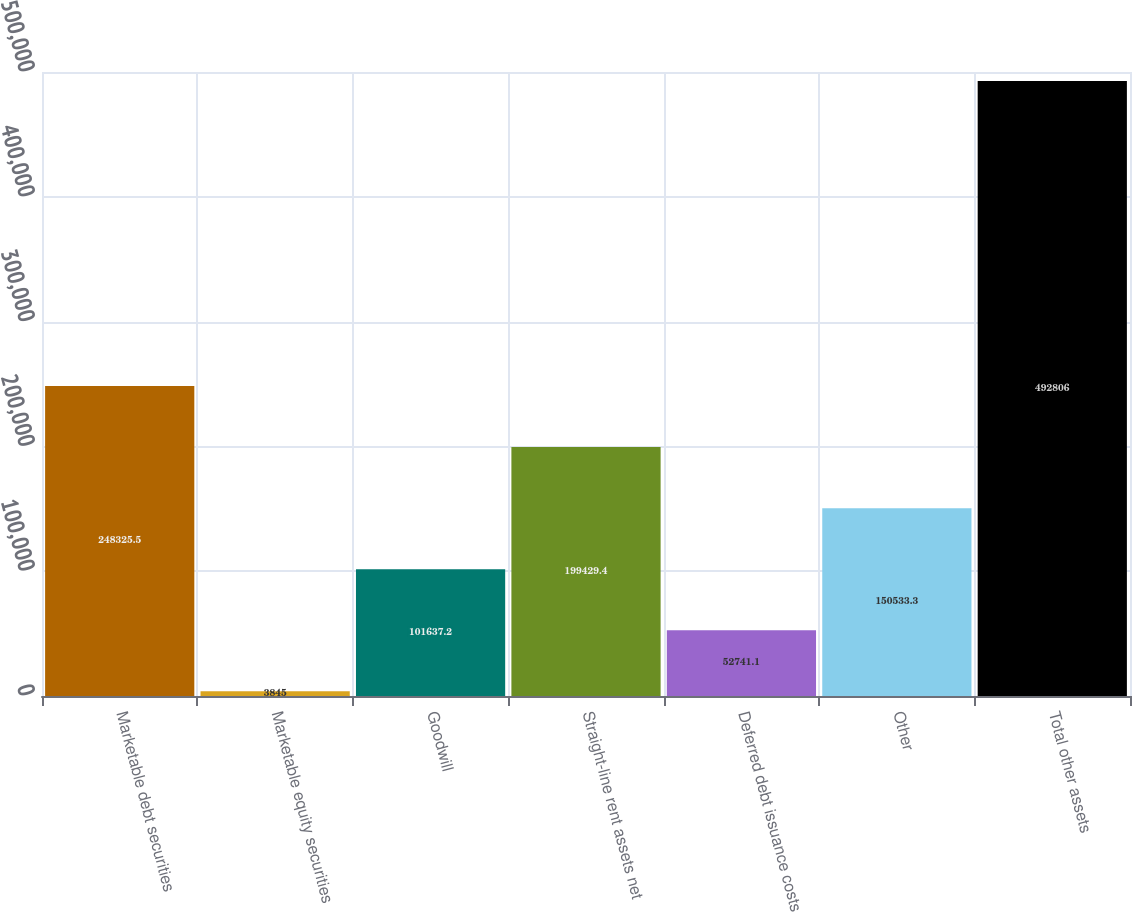Convert chart to OTSL. <chart><loc_0><loc_0><loc_500><loc_500><bar_chart><fcel>Marketable debt securities<fcel>Marketable equity securities<fcel>Goodwill<fcel>Straight-line rent assets net<fcel>Deferred debt issuance costs<fcel>Other<fcel>Total other assets<nl><fcel>248326<fcel>3845<fcel>101637<fcel>199429<fcel>52741.1<fcel>150533<fcel>492806<nl></chart> 